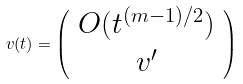Convert formula to latex. <formula><loc_0><loc_0><loc_500><loc_500>v ( t ) = \left ( \begin{array} { c } { { O ( t ^ { ( m - 1 ) / 2 } ) } } \\ { { v ^ { \prime } } } \end{array} \right )</formula> 